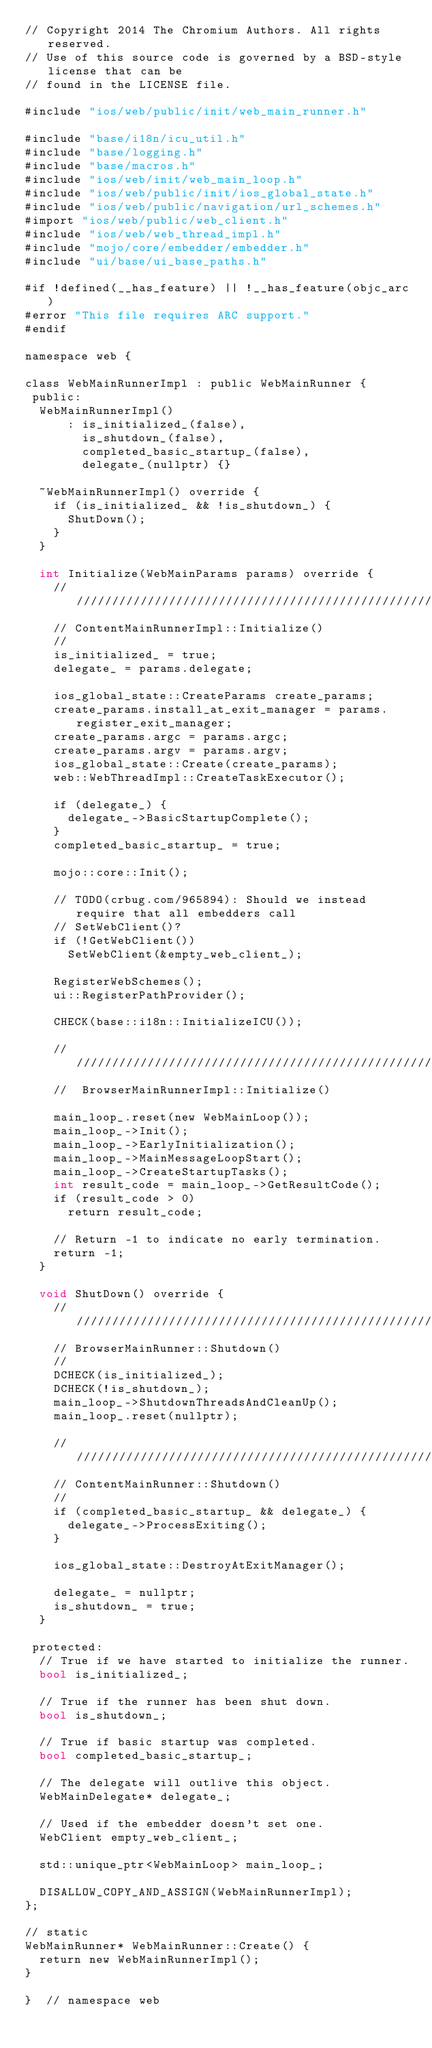<code> <loc_0><loc_0><loc_500><loc_500><_ObjectiveC_>// Copyright 2014 The Chromium Authors. All rights reserved.
// Use of this source code is governed by a BSD-style license that can be
// found in the LICENSE file.

#include "ios/web/public/init/web_main_runner.h"

#include "base/i18n/icu_util.h"
#include "base/logging.h"
#include "base/macros.h"
#include "ios/web/init/web_main_loop.h"
#include "ios/web/public/init/ios_global_state.h"
#include "ios/web/public/navigation/url_schemes.h"
#import "ios/web/public/web_client.h"
#include "ios/web/web_thread_impl.h"
#include "mojo/core/embedder/embedder.h"
#include "ui/base/ui_base_paths.h"

#if !defined(__has_feature) || !__has_feature(objc_arc)
#error "This file requires ARC support."
#endif

namespace web {

class WebMainRunnerImpl : public WebMainRunner {
 public:
  WebMainRunnerImpl()
      : is_initialized_(false),
        is_shutdown_(false),
        completed_basic_startup_(false),
        delegate_(nullptr) {}

  ~WebMainRunnerImpl() override {
    if (is_initialized_ && !is_shutdown_) {
      ShutDown();
    }
  }

  int Initialize(WebMainParams params) override {
    ////////////////////////////////////////////////////////////////////////
    // ContentMainRunnerImpl::Initialize()
    //
    is_initialized_ = true;
    delegate_ = params.delegate;

    ios_global_state::CreateParams create_params;
    create_params.install_at_exit_manager = params.register_exit_manager;
    create_params.argc = params.argc;
    create_params.argv = params.argv;
    ios_global_state::Create(create_params);
    web::WebThreadImpl::CreateTaskExecutor();

    if (delegate_) {
      delegate_->BasicStartupComplete();
    }
    completed_basic_startup_ = true;

    mojo::core::Init();

    // TODO(crbug.com/965894): Should we instead require that all embedders call
    // SetWebClient()?
    if (!GetWebClient())
      SetWebClient(&empty_web_client_);

    RegisterWebSchemes();
    ui::RegisterPathProvider();

    CHECK(base::i18n::InitializeICU());

    ////////////////////////////////////////////////////////////
    //  BrowserMainRunnerImpl::Initialize()

    main_loop_.reset(new WebMainLoop());
    main_loop_->Init();
    main_loop_->EarlyInitialization();
    main_loop_->MainMessageLoopStart();
    main_loop_->CreateStartupTasks();
    int result_code = main_loop_->GetResultCode();
    if (result_code > 0)
      return result_code;

    // Return -1 to indicate no early termination.
    return -1;
  }

  void ShutDown() override {
    ////////////////////////////////////////////////////////////////////
    // BrowserMainRunner::Shutdown()
    //
    DCHECK(is_initialized_);
    DCHECK(!is_shutdown_);
    main_loop_->ShutdownThreadsAndCleanUp();
    main_loop_.reset(nullptr);

    ////////////////////////////////////////////////////////////////////
    // ContentMainRunner::Shutdown()
    //
    if (completed_basic_startup_ && delegate_) {
      delegate_->ProcessExiting();
    }

    ios_global_state::DestroyAtExitManager();

    delegate_ = nullptr;
    is_shutdown_ = true;
  }

 protected:
  // True if we have started to initialize the runner.
  bool is_initialized_;

  // True if the runner has been shut down.
  bool is_shutdown_;

  // True if basic startup was completed.
  bool completed_basic_startup_;

  // The delegate will outlive this object.
  WebMainDelegate* delegate_;

  // Used if the embedder doesn't set one.
  WebClient empty_web_client_;

  std::unique_ptr<WebMainLoop> main_loop_;

  DISALLOW_COPY_AND_ASSIGN(WebMainRunnerImpl);
};

// static
WebMainRunner* WebMainRunner::Create() {
  return new WebMainRunnerImpl();
}

}  // namespace web
</code> 